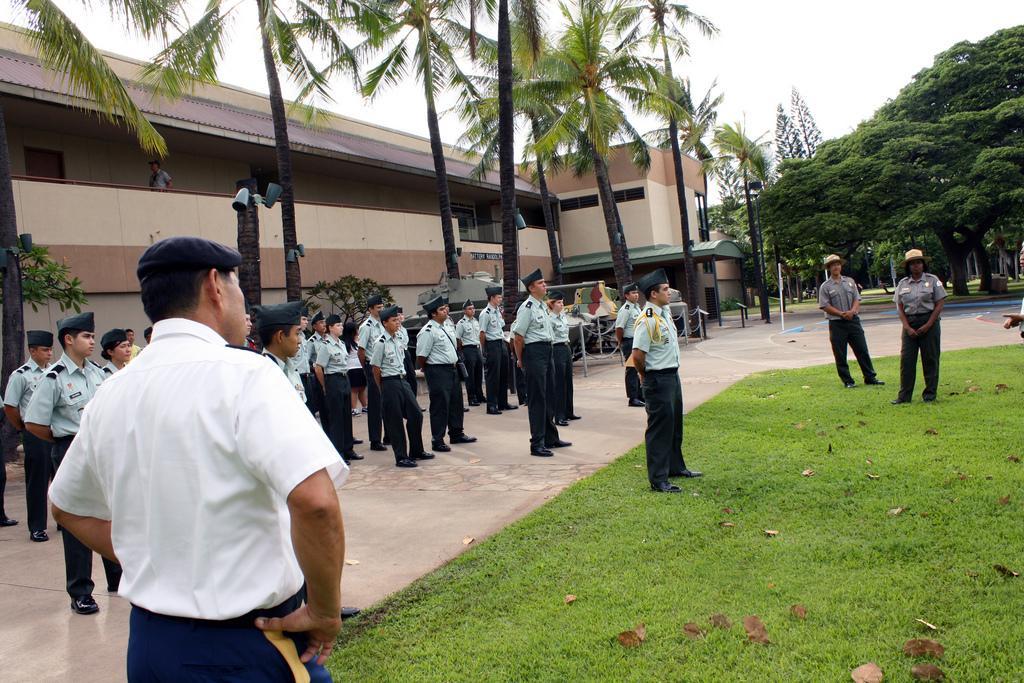Describe this image in one or two sentences. In the picture I can see group of people are standing on the ground. These people are wearing uniforms and hats. In the background I can see a building, trees, the grass and some other objects on the ground. 